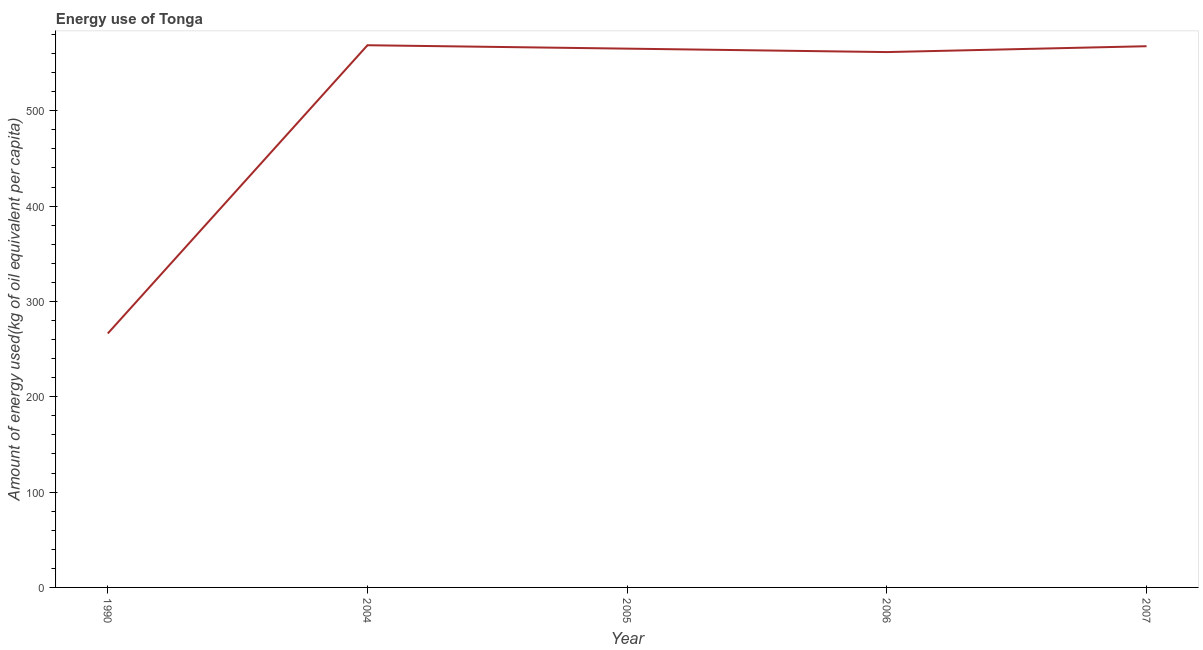What is the amount of energy used in 2004?
Your answer should be very brief. 568.71. Across all years, what is the maximum amount of energy used?
Provide a short and direct response. 568.71. Across all years, what is the minimum amount of energy used?
Offer a very short reply. 266.37. In which year was the amount of energy used maximum?
Offer a very short reply. 2004. In which year was the amount of energy used minimum?
Keep it short and to the point. 1990. What is the sum of the amount of energy used?
Keep it short and to the point. 2529.46. What is the difference between the amount of energy used in 2005 and 2007?
Your response must be concise. -2.54. What is the average amount of energy used per year?
Provide a short and direct response. 505.89. What is the median amount of energy used?
Ensure brevity in your answer.  565.15. Do a majority of the years between 2004 and 2005 (inclusive) have amount of energy used greater than 540 kg?
Provide a succinct answer. Yes. What is the ratio of the amount of energy used in 1990 to that in 2005?
Offer a very short reply. 0.47. Is the amount of energy used in 2006 less than that in 2007?
Provide a short and direct response. Yes. Is the difference between the amount of energy used in 1990 and 2007 greater than the difference between any two years?
Offer a very short reply. No. What is the difference between the highest and the second highest amount of energy used?
Offer a terse response. 1.03. Is the sum of the amount of energy used in 1990 and 2005 greater than the maximum amount of energy used across all years?
Keep it short and to the point. Yes. What is the difference between the highest and the lowest amount of energy used?
Provide a short and direct response. 302.35. Does the amount of energy used monotonically increase over the years?
Your answer should be very brief. No. How many years are there in the graph?
Offer a terse response. 5. What is the difference between two consecutive major ticks on the Y-axis?
Give a very brief answer. 100. Does the graph contain any zero values?
Make the answer very short. No. What is the title of the graph?
Give a very brief answer. Energy use of Tonga. What is the label or title of the Y-axis?
Provide a short and direct response. Amount of energy used(kg of oil equivalent per capita). What is the Amount of energy used(kg of oil equivalent per capita) in 1990?
Give a very brief answer. 266.37. What is the Amount of energy used(kg of oil equivalent per capita) in 2004?
Give a very brief answer. 568.71. What is the Amount of energy used(kg of oil equivalent per capita) of 2005?
Make the answer very short. 565.15. What is the Amount of energy used(kg of oil equivalent per capita) in 2006?
Offer a very short reply. 561.54. What is the Amount of energy used(kg of oil equivalent per capita) of 2007?
Ensure brevity in your answer.  567.69. What is the difference between the Amount of energy used(kg of oil equivalent per capita) in 1990 and 2004?
Offer a very short reply. -302.35. What is the difference between the Amount of energy used(kg of oil equivalent per capita) in 1990 and 2005?
Offer a terse response. -298.78. What is the difference between the Amount of energy used(kg of oil equivalent per capita) in 1990 and 2006?
Your answer should be very brief. -295.17. What is the difference between the Amount of energy used(kg of oil equivalent per capita) in 1990 and 2007?
Offer a terse response. -301.32. What is the difference between the Amount of energy used(kg of oil equivalent per capita) in 2004 and 2005?
Your answer should be compact. 3.56. What is the difference between the Amount of energy used(kg of oil equivalent per capita) in 2004 and 2006?
Provide a short and direct response. 7.18. What is the difference between the Amount of energy used(kg of oil equivalent per capita) in 2004 and 2007?
Provide a succinct answer. 1.03. What is the difference between the Amount of energy used(kg of oil equivalent per capita) in 2005 and 2006?
Offer a very short reply. 3.61. What is the difference between the Amount of energy used(kg of oil equivalent per capita) in 2005 and 2007?
Provide a succinct answer. -2.54. What is the difference between the Amount of energy used(kg of oil equivalent per capita) in 2006 and 2007?
Your response must be concise. -6.15. What is the ratio of the Amount of energy used(kg of oil equivalent per capita) in 1990 to that in 2004?
Offer a terse response. 0.47. What is the ratio of the Amount of energy used(kg of oil equivalent per capita) in 1990 to that in 2005?
Offer a very short reply. 0.47. What is the ratio of the Amount of energy used(kg of oil equivalent per capita) in 1990 to that in 2006?
Offer a terse response. 0.47. What is the ratio of the Amount of energy used(kg of oil equivalent per capita) in 1990 to that in 2007?
Offer a terse response. 0.47. What is the ratio of the Amount of energy used(kg of oil equivalent per capita) in 2004 to that in 2006?
Provide a succinct answer. 1.01. What is the ratio of the Amount of energy used(kg of oil equivalent per capita) in 2006 to that in 2007?
Provide a succinct answer. 0.99. 